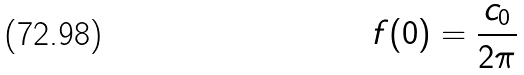<formula> <loc_0><loc_0><loc_500><loc_500>f ( 0 ) = \frac { c _ { 0 } } { 2 \pi }</formula> 